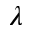Convert formula to latex. <formula><loc_0><loc_0><loc_500><loc_500>\lambda</formula> 